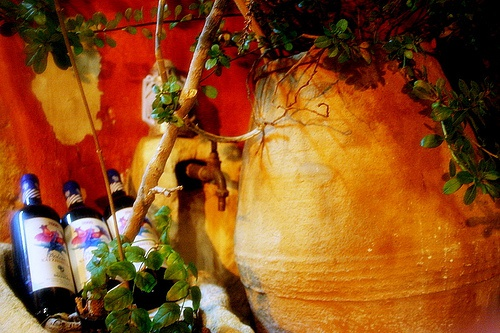Describe the objects in this image and their specific colors. I can see vase in black, red, orange, and brown tones, bottle in black, lavender, tan, and navy tones, bottle in black, lavender, maroon, and tan tones, and bottle in black, lavender, olive, and maroon tones in this image. 